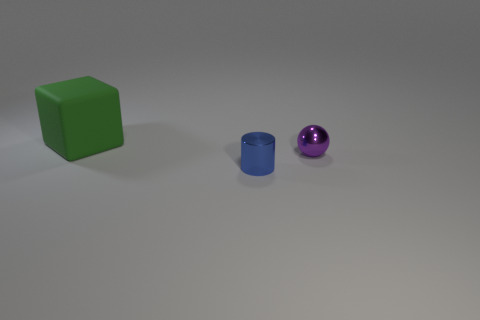Add 2 big metal things. How many objects exist? 5 Add 3 cylinders. How many cylinders are left? 4 Add 3 tiny purple metal balls. How many tiny purple metal balls exist? 4 Subtract 0 blue cubes. How many objects are left? 3 Subtract 1 blocks. How many blocks are left? 0 Subtract all blue blocks. Subtract all blue balls. How many blocks are left? 1 Subtract all cyan cubes. How many brown cylinders are left? 0 Subtract all large cyan matte things. Subtract all small purple objects. How many objects are left? 2 